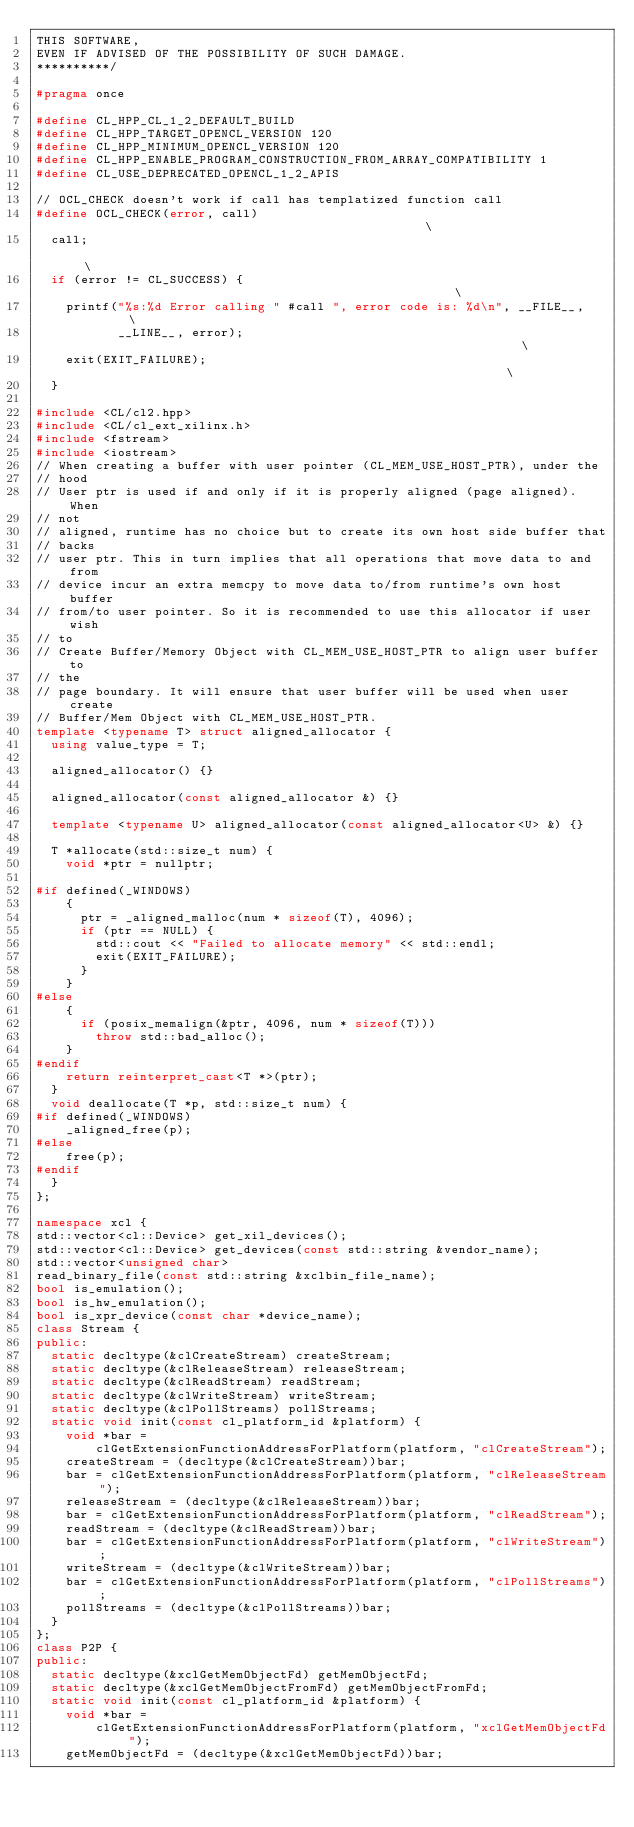<code> <loc_0><loc_0><loc_500><loc_500><_C++_>THIS SOFTWARE,
EVEN IF ADVISED OF THE POSSIBILITY OF SUCH DAMAGE.
**********/

#pragma once

#define CL_HPP_CL_1_2_DEFAULT_BUILD
#define CL_HPP_TARGET_OPENCL_VERSION 120
#define CL_HPP_MINIMUM_OPENCL_VERSION 120
#define CL_HPP_ENABLE_PROGRAM_CONSTRUCTION_FROM_ARRAY_COMPATIBILITY 1
#define CL_USE_DEPRECATED_OPENCL_1_2_APIS

// OCL_CHECK doesn't work if call has templatized function call
#define OCL_CHECK(error, call)                                                 \
  call;                                                                        \
  if (error != CL_SUCCESS) {                                                   \
    printf("%s:%d Error calling " #call ", error code is: %d\n", __FILE__,     \
           __LINE__, error);                                                   \
    exit(EXIT_FAILURE);                                                        \
  }

#include <CL/cl2.hpp>
#include <CL/cl_ext_xilinx.h>
#include <fstream>
#include <iostream>
// When creating a buffer with user pointer (CL_MEM_USE_HOST_PTR), under the
// hood
// User ptr is used if and only if it is properly aligned (page aligned). When
// not
// aligned, runtime has no choice but to create its own host side buffer that
// backs
// user ptr. This in turn implies that all operations that move data to and from
// device incur an extra memcpy to move data to/from runtime's own host buffer
// from/to user pointer. So it is recommended to use this allocator if user wish
// to
// Create Buffer/Memory Object with CL_MEM_USE_HOST_PTR to align user buffer to
// the
// page boundary. It will ensure that user buffer will be used when user create
// Buffer/Mem Object with CL_MEM_USE_HOST_PTR.
template <typename T> struct aligned_allocator {
  using value_type = T;

  aligned_allocator() {}

  aligned_allocator(const aligned_allocator &) {}

  template <typename U> aligned_allocator(const aligned_allocator<U> &) {}

  T *allocate(std::size_t num) {
    void *ptr = nullptr;

#if defined(_WINDOWS)
    {
      ptr = _aligned_malloc(num * sizeof(T), 4096);
      if (ptr == NULL) {
        std::cout << "Failed to allocate memory" << std::endl;
        exit(EXIT_FAILURE);
      }
    }
#else
    {
      if (posix_memalign(&ptr, 4096, num * sizeof(T)))
        throw std::bad_alloc();
    }
#endif
    return reinterpret_cast<T *>(ptr);
  }
  void deallocate(T *p, std::size_t num) {
#if defined(_WINDOWS)
    _aligned_free(p);
#else
    free(p);
#endif
  }
};

namespace xcl {
std::vector<cl::Device> get_xil_devices();
std::vector<cl::Device> get_devices(const std::string &vendor_name);
std::vector<unsigned char>
read_binary_file(const std::string &xclbin_file_name);
bool is_emulation();
bool is_hw_emulation();
bool is_xpr_device(const char *device_name);
class Stream {
public:
  static decltype(&clCreateStream) createStream;
  static decltype(&clReleaseStream) releaseStream;
  static decltype(&clReadStream) readStream;
  static decltype(&clWriteStream) writeStream;
  static decltype(&clPollStreams) pollStreams;
  static void init(const cl_platform_id &platform) {
    void *bar =
        clGetExtensionFunctionAddressForPlatform(platform, "clCreateStream");
    createStream = (decltype(&clCreateStream))bar;
    bar = clGetExtensionFunctionAddressForPlatform(platform, "clReleaseStream");
    releaseStream = (decltype(&clReleaseStream))bar;
    bar = clGetExtensionFunctionAddressForPlatform(platform, "clReadStream");
    readStream = (decltype(&clReadStream))bar;
    bar = clGetExtensionFunctionAddressForPlatform(platform, "clWriteStream");
    writeStream = (decltype(&clWriteStream))bar;
    bar = clGetExtensionFunctionAddressForPlatform(platform, "clPollStreams");
    pollStreams = (decltype(&clPollStreams))bar;
  }
};
class P2P {
public:
  static decltype(&xclGetMemObjectFd) getMemObjectFd;
  static decltype(&xclGetMemObjectFromFd) getMemObjectFromFd;
  static void init(const cl_platform_id &platform) {
    void *bar =
        clGetExtensionFunctionAddressForPlatform(platform, "xclGetMemObjectFd");
    getMemObjectFd = (decltype(&xclGetMemObjectFd))bar;</code> 